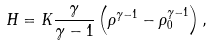<formula> <loc_0><loc_0><loc_500><loc_500>H = K \frac { \gamma } { \gamma - 1 } \left ( \rho ^ { \gamma - 1 } - \rho _ { 0 } ^ { \gamma - 1 } \right ) ,</formula> 